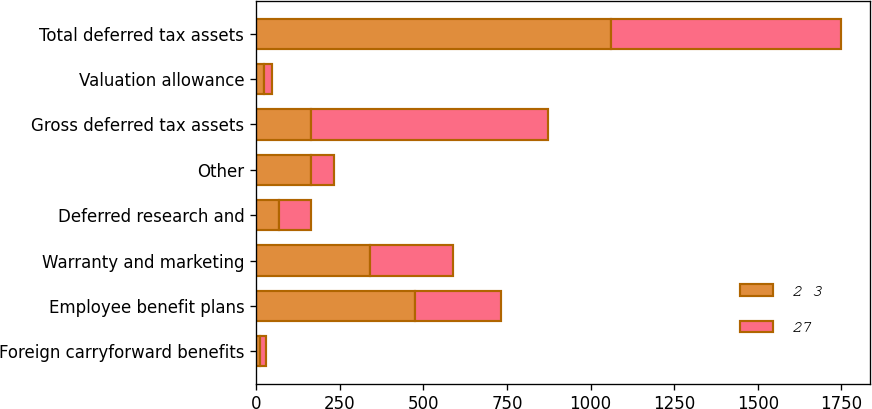<chart> <loc_0><loc_0><loc_500><loc_500><stacked_bar_chart><ecel><fcel>Foreign carryforward benefits<fcel>Employee benefit plans<fcel>Warranty and marketing<fcel>Deferred research and<fcel>Other<fcel>Gross deferred tax assets<fcel>Valuation allowance<fcel>Total deferred tax assets<nl><fcel>2 3<fcel>13<fcel>474<fcel>341<fcel>68<fcel>163<fcel>163<fcel>25<fcel>1061<nl><fcel>27<fcel>16<fcel>257<fcel>247<fcel>97<fcel>71<fcel>711<fcel>24<fcel>687<nl></chart> 